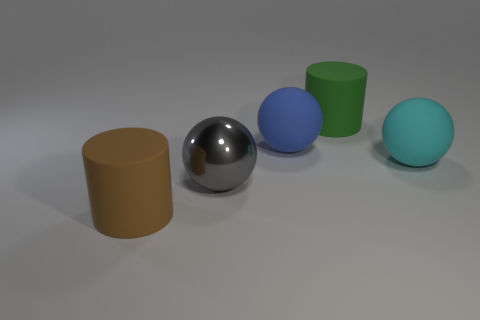There is a gray object that is the same size as the brown cylinder; what material is it?
Offer a terse response. Metal. There is a matte cylinder right of the big matte thing in front of the cyan rubber thing; are there any matte objects to the left of it?
Offer a terse response. Yes. Are any metallic objects visible?
Provide a succinct answer. Yes. There is a rubber cylinder that is in front of the cylinder that is behind the large rubber cylinder that is in front of the metallic object; how big is it?
Make the answer very short. Large. There is a cyan matte thing; is it the same shape as the big metal object that is in front of the green rubber cylinder?
Make the answer very short. Yes. What number of spheres are large purple objects or green objects?
Offer a very short reply. 0. Is there a rubber object that has the same shape as the gray shiny object?
Your answer should be compact. Yes. Are there fewer matte cylinders that are to the left of the gray metal ball than rubber spheres?
Make the answer very short. Yes. How many large purple metallic things are there?
Your answer should be compact. 0. How many brown cylinders have the same material as the big cyan sphere?
Ensure brevity in your answer.  1. 